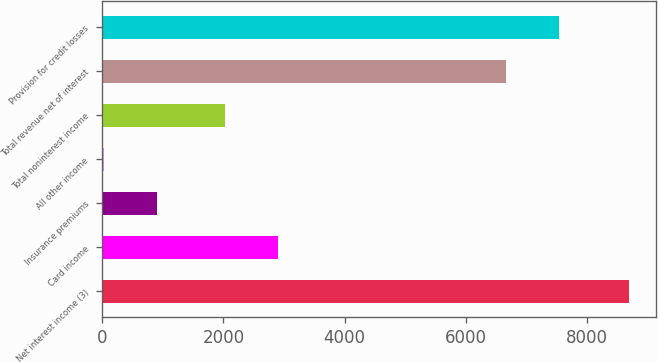<chart> <loc_0><loc_0><loc_500><loc_500><bar_chart><fcel>Net interest income (3)<fcel>Card income<fcel>Insurance premiums<fcel>All other income<fcel>Total noninterest income<fcel>Total revenue net of interest<fcel>Provision for credit losses<nl><fcel>8701<fcel>2897.8<fcel>899.8<fcel>33<fcel>2031<fcel>6670<fcel>7536.8<nl></chart> 